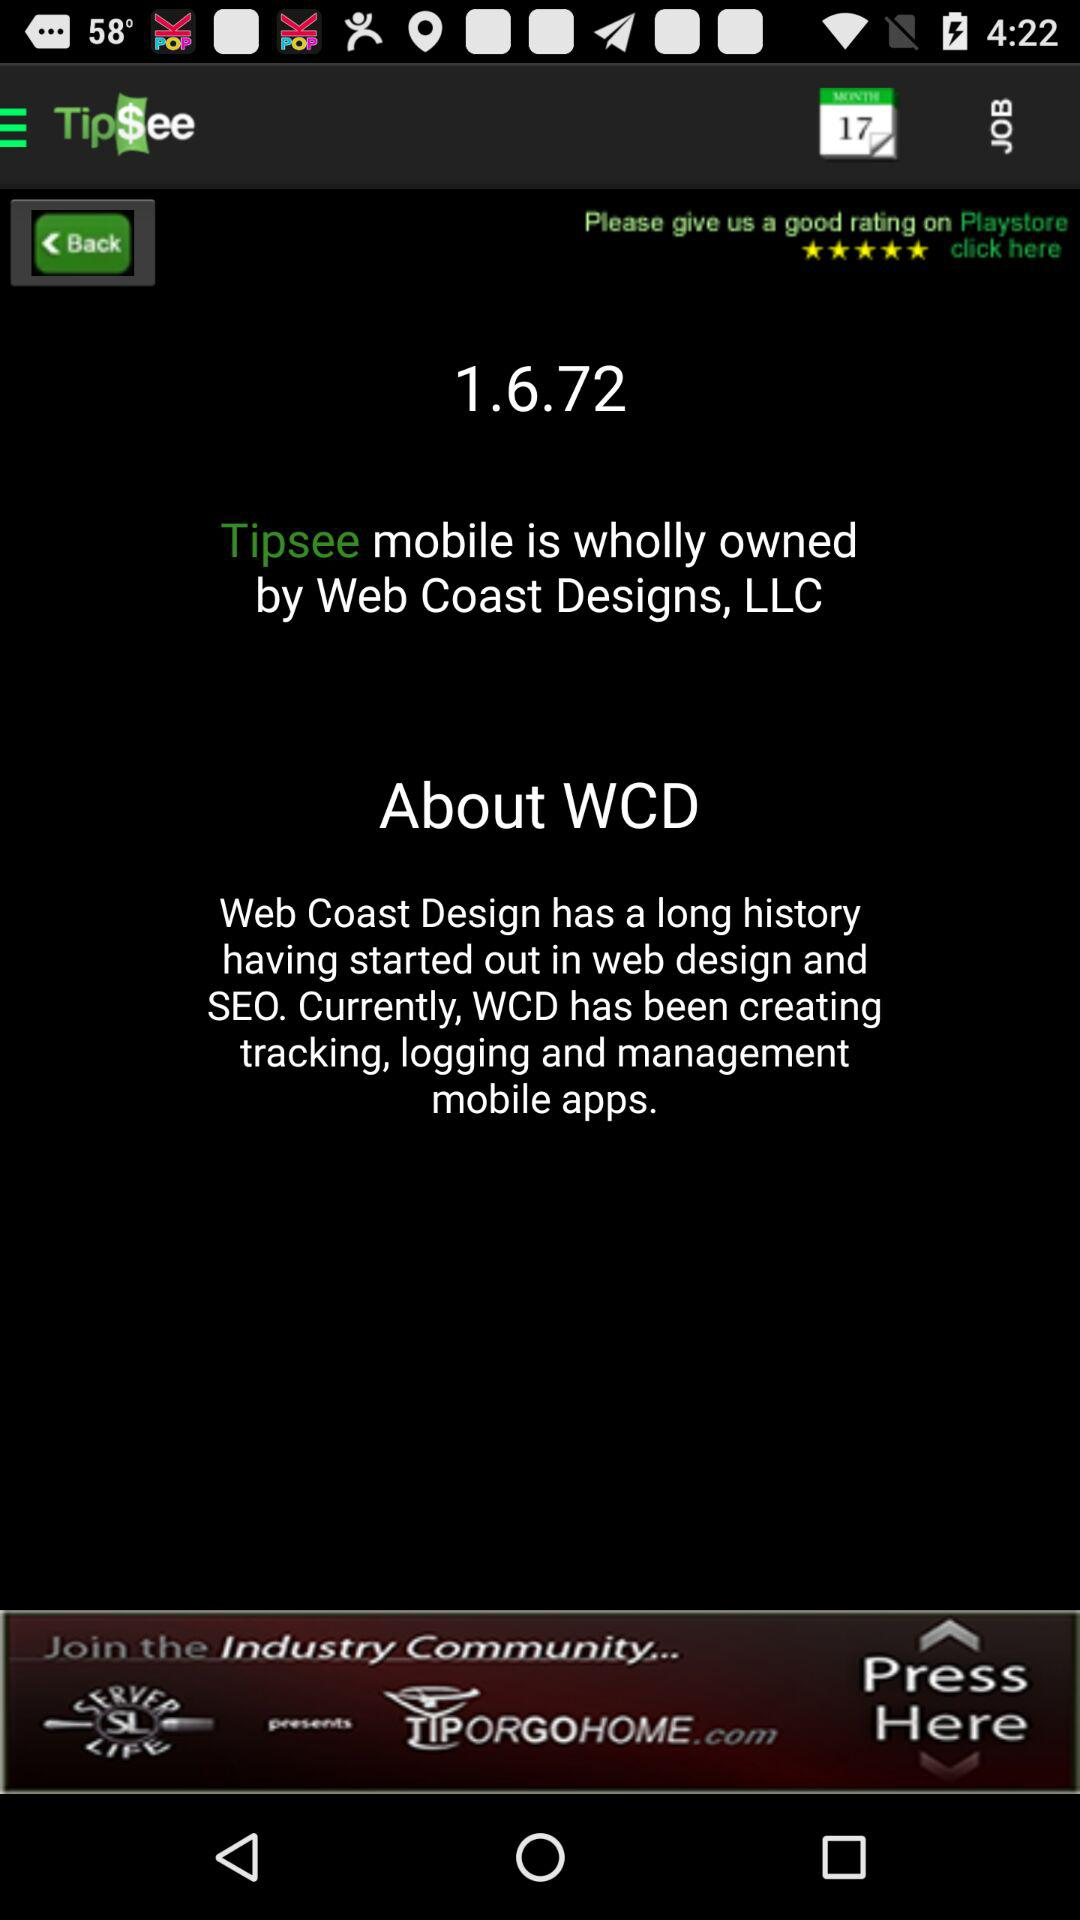How many hours have been worked this week?
Answer the question using a single word or phrase. 0.0 hrs 